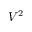<formula> <loc_0><loc_0><loc_500><loc_500>V ^ { 2 }</formula> 